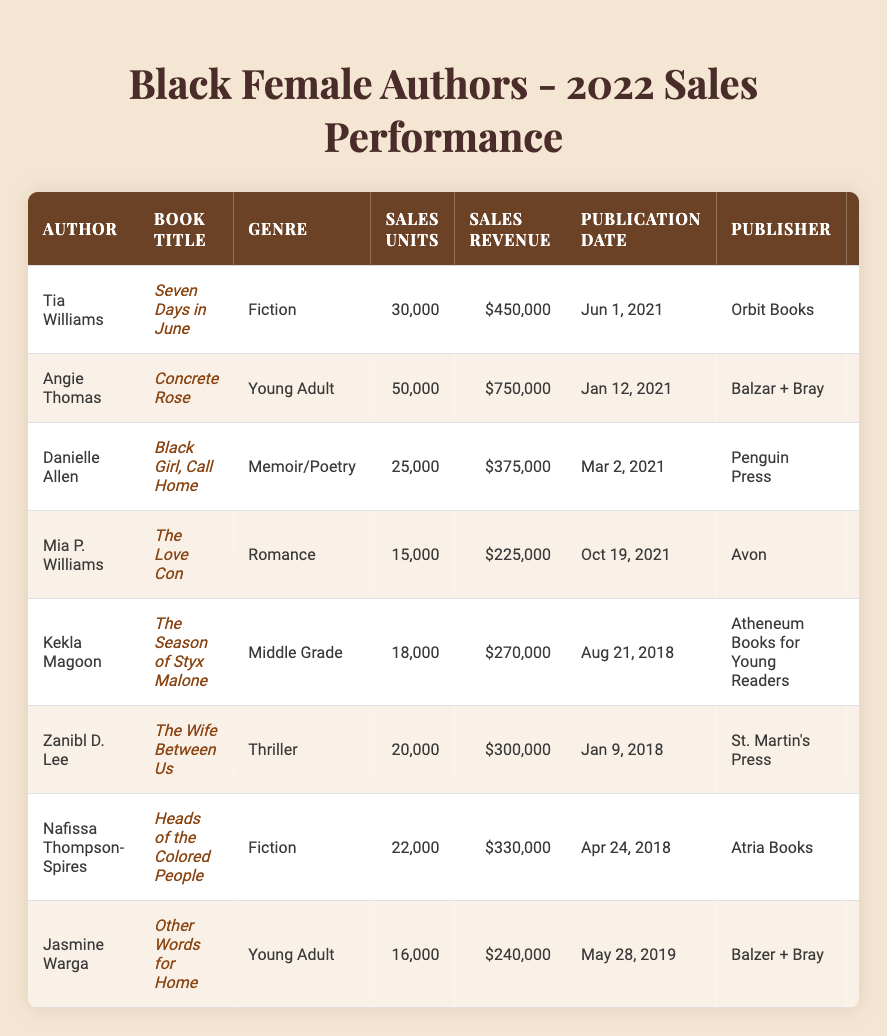What is the book title by Angie Thomas? The table lists the author's name as Angie Thomas; the corresponding book title next to her name is "Concrete Rose."
Answer: Concrete Rose How many sales units did Tia Williams’ book achieve? By locating Tia Williams in the table, the sales units column shows the number as 30,000.
Answer: 30,000 What is the total sales revenue for the books by Danielle Allen and Mia P. Williams combined? To find the total, look up the sales revenue for Danielle Allen, which is $375,000, and for Mia P. Williams, which is $225,000. Adding these gives: $375,000 + $225,000 = $600,000.
Answer: $600,000 Which author has the highest average rating? The average ratings for authors can be compared: Tia Williams: 4.5, Angie Thomas: 4.8, Danielle Allen: 4.6, Mia P. Williams: 4.3, Kekla Magoon: 4.4, Zanibl D. Lee: 4.2, Nafissa Thompson-Spires: 4.5, and Jasmine Warga: 4.6. The highest is Angie Thomas with 4.8.
Answer: Angie Thomas How many total reviews did all the authors receive? To find the total reviews, add together the number of reviews for each book: 1,200 + 2,300 + 900 + 640 + 500 + 760 + 860 + 700 = 7,860.
Answer: 7,860 Which book had the lowest sales revenue? By comparing the sales revenue, Mia P. Williams’ book "The Love Con" has the lowest revenue at $225,000, which is less than the other listed books.
Answer: The Love Con Did any of the books published in 2021 win an award? Checking the list, both "Seven Days in June" by Tia Williams and "Concrete Rose" by Angie Thomas, published in 2021, won awards. Therefore, the answer is yes.
Answer: Yes How many books listed fall under the genre "Young Adult"? The authors Angie Thomas and Jasmine Warga both authored "Concrete Rose" and "Other Words for Home," respectively. Therefore, there are 2 books in the "Young Adult" genre.
Answer: 2 What is the average sales units of all the books listed? To calculate the average, sum all sales units (30,000 + 50,000 + 25,000 + 15,000 + 18,000 + 20,000 + 22,000 + 16,000 = 206,000) and divide by the number of books (8): 206,000 / 8 = 25,750.
Answer: 25,750 Which author has the least number of reviews for their book? Reviews are as follows: 1,200(Tia Williams), 2,300(Angie Thomas), 900(Danielle Allen), 640(Mia P. Williams), 500(Kekla Magoon), 760(Zanibl D. Lee), 860(Nafissa Thompson-Spires), and 700(Jasmine Warga). The least are 500 reviews by Kekla Magoon.
Answer: Kekla Magoon Is there a relationship between the total sales revenue and the average rating? A quick look suggests that books with higher sales revenue (like "Concrete Rose" with $750,000) also tend to have higher average ratings (4.8). This suggests a positive correlation, but the exact relationship would require more specific statistical analysis. So, the answer is not definitively yes or no without further analysis.
Answer: Not definitively quantifiable 